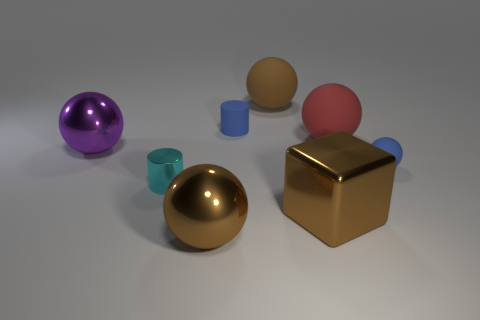Subtract 2 balls. How many balls are left? 3 Subtract all small balls. How many balls are left? 4 Subtract all purple spheres. How many spheres are left? 4 Subtract all gray spheres. Subtract all green cylinders. How many spheres are left? 5 Add 2 big gray rubber balls. How many objects exist? 10 Subtract all cylinders. How many objects are left? 6 Subtract 0 green cylinders. How many objects are left? 8 Subtract all gray shiny things. Subtract all large purple metallic things. How many objects are left? 7 Add 4 tiny rubber balls. How many tiny rubber balls are left? 5 Add 2 purple balls. How many purple balls exist? 3 